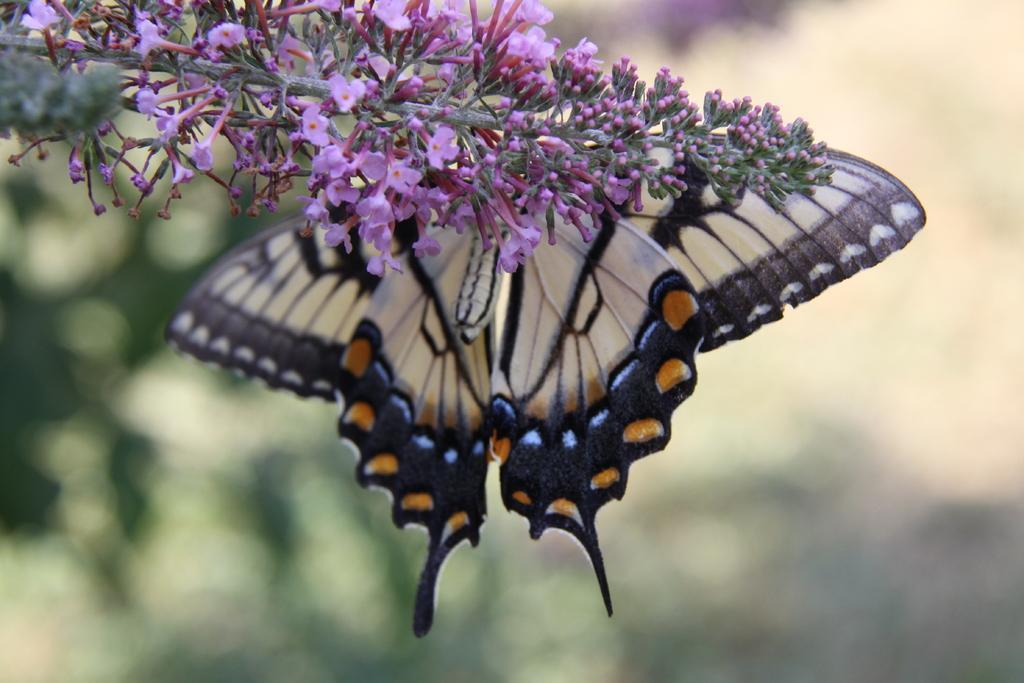Please provide a concise description of this image. In the foreground of this picture, there is a white colored butterfly on the plant and we can also see pink colored flowers to the plant and the background is blurred. 